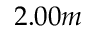<formula> <loc_0><loc_0><loc_500><loc_500>2 . 0 0 m</formula> 